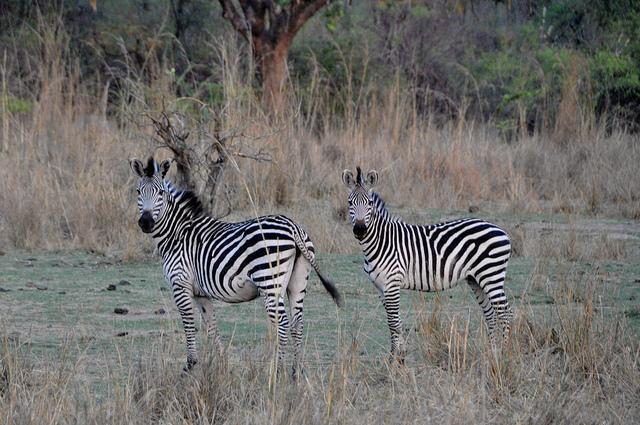How many zebras are there?
Give a very brief answer. 2. 